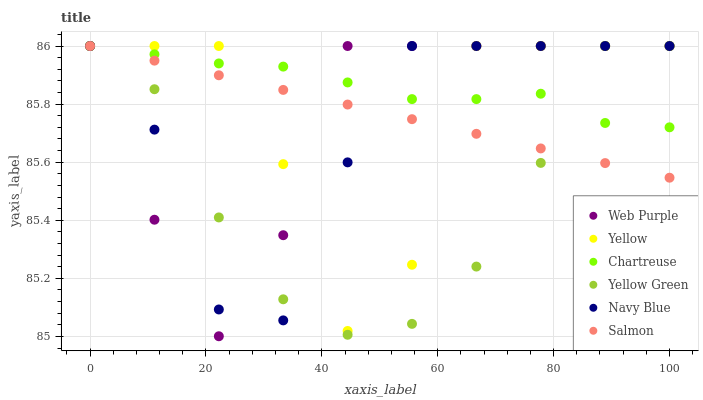Does Yellow Green have the minimum area under the curve?
Answer yes or no. Yes. Does Chartreuse have the maximum area under the curve?
Answer yes or no. Yes. Does Navy Blue have the minimum area under the curve?
Answer yes or no. No. Does Navy Blue have the maximum area under the curve?
Answer yes or no. No. Is Salmon the smoothest?
Answer yes or no. Yes. Is Yellow the roughest?
Answer yes or no. Yes. Is Navy Blue the smoothest?
Answer yes or no. No. Is Navy Blue the roughest?
Answer yes or no. No. Does Web Purple have the lowest value?
Answer yes or no. Yes. Does Navy Blue have the lowest value?
Answer yes or no. No. Does Web Purple have the highest value?
Answer yes or no. Yes. Does Salmon intersect Yellow?
Answer yes or no. Yes. Is Salmon less than Yellow?
Answer yes or no. No. Is Salmon greater than Yellow?
Answer yes or no. No. 